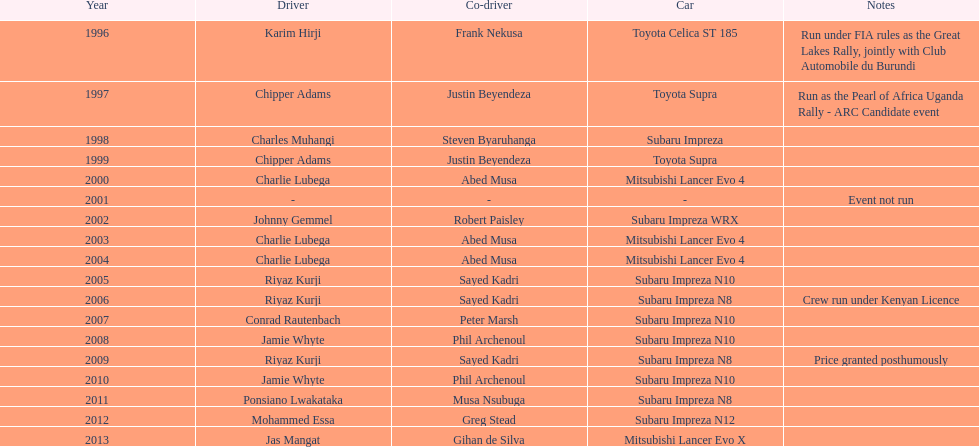Are there more than three wins for chipper adams and justin beyendeza? No. 